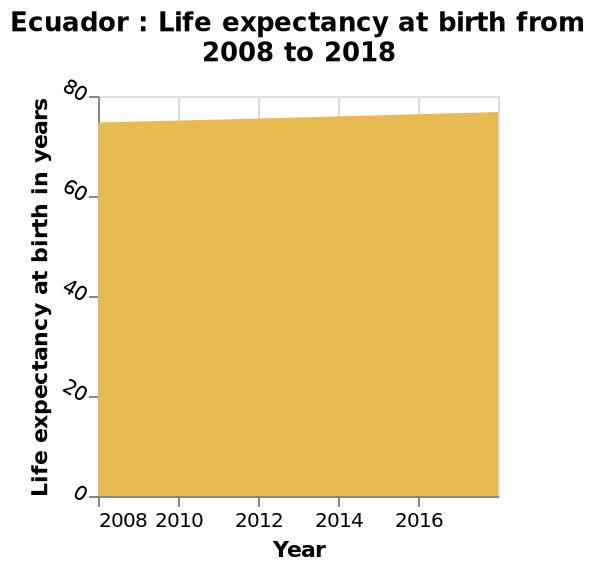<image>
Offer a thorough analysis of the image. The life expectancy rate has continues to rise slowly over the past ten years. please describe the details of the chart Ecuador : Life expectancy at birth from 2008 to 2018 is a area chart. The x-axis shows Year as a linear scale from 2008 to 2016. A linear scale of range 0 to 80 can be found along the y-axis, marked Life expectancy at birth in years. How has the life expectancy rate changed over the past ten years? The life expectancy rate has risen slowly. Has the life expectancy rate been increasing or decreasing over the past ten years?  The life expectancy rate has been increasing. What is the title of the y-axis? The title of the y-axis is "Life expectancy at birth in years." 